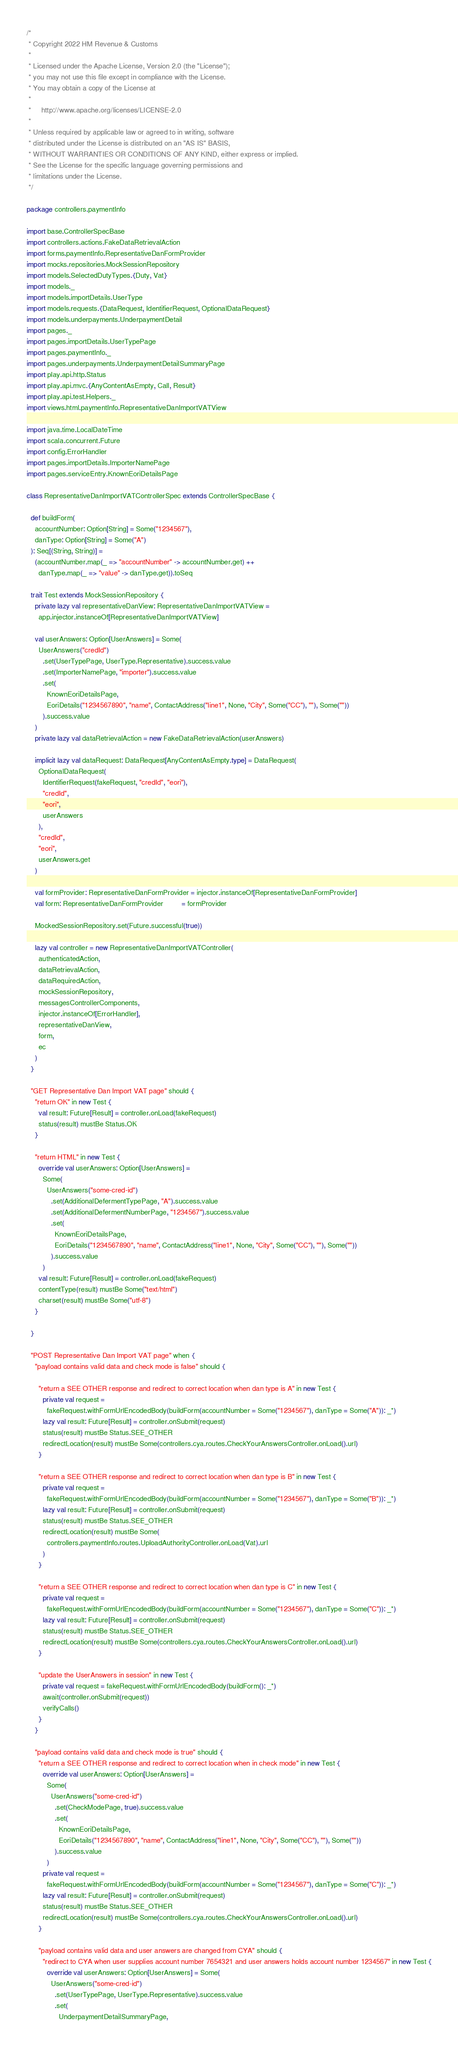<code> <loc_0><loc_0><loc_500><loc_500><_Scala_>/*
 * Copyright 2022 HM Revenue & Customs
 *
 * Licensed under the Apache License, Version 2.0 (the "License");
 * you may not use this file except in compliance with the License.
 * You may obtain a copy of the License at
 *
 *     http://www.apache.org/licenses/LICENSE-2.0
 *
 * Unless required by applicable law or agreed to in writing, software
 * distributed under the License is distributed on an "AS IS" BASIS,
 * WITHOUT WARRANTIES OR CONDITIONS OF ANY KIND, either express or implied.
 * See the License for the specific language governing permissions and
 * limitations under the License.
 */

package controllers.paymentInfo

import base.ControllerSpecBase
import controllers.actions.FakeDataRetrievalAction
import forms.paymentInfo.RepresentativeDanFormProvider
import mocks.repositories.MockSessionRepository
import models.SelectedDutyTypes.{Duty, Vat}
import models._
import models.importDetails.UserType
import models.requests.{DataRequest, IdentifierRequest, OptionalDataRequest}
import models.underpayments.UnderpaymentDetail
import pages._
import pages.importDetails.UserTypePage
import pages.paymentInfo._
import pages.underpayments.UnderpaymentDetailSummaryPage
import play.api.http.Status
import play.api.mvc.{AnyContentAsEmpty, Call, Result}
import play.api.test.Helpers._
import views.html.paymentInfo.RepresentativeDanImportVATView

import java.time.LocalDateTime
import scala.concurrent.Future
import config.ErrorHandler
import pages.importDetails.ImporterNamePage
import pages.serviceEntry.KnownEoriDetailsPage

class RepresentativeDanImportVATControllerSpec extends ControllerSpecBase {

  def buildForm(
    accountNumber: Option[String] = Some("1234567"),
    danType: Option[String] = Some("A")
  ): Seq[(String, String)] =
    (accountNumber.map(_ => "accountNumber" -> accountNumber.get) ++
      danType.map(_ => "value" -> danType.get)).toSeq

  trait Test extends MockSessionRepository {
    private lazy val representativeDanView: RepresentativeDanImportVATView =
      app.injector.instanceOf[RepresentativeDanImportVATView]

    val userAnswers: Option[UserAnswers] = Some(
      UserAnswers("credId")
        .set(UserTypePage, UserType.Representative).success.value
        .set(ImporterNamePage, "importer").success.value
        .set(
          KnownEoriDetailsPage,
          EoriDetails("1234567890", "name", ContactAddress("line1", None, "City", Some("CC"), ""), Some(""))
        ).success.value
    )
    private lazy val dataRetrievalAction = new FakeDataRetrievalAction(userAnswers)

    implicit lazy val dataRequest: DataRequest[AnyContentAsEmpty.type] = DataRequest(
      OptionalDataRequest(
        IdentifierRequest(fakeRequest, "credId", "eori"),
        "credId",
        "eori",
        userAnswers
      ),
      "credId",
      "eori",
      userAnswers.get
    )

    val formProvider: RepresentativeDanFormProvider = injector.instanceOf[RepresentativeDanFormProvider]
    val form: RepresentativeDanFormProvider         = formProvider

    MockedSessionRepository.set(Future.successful(true))

    lazy val controller = new RepresentativeDanImportVATController(
      authenticatedAction,
      dataRetrievalAction,
      dataRequiredAction,
      mockSessionRepository,
      messagesControllerComponents,
      injector.instanceOf[ErrorHandler],
      representativeDanView,
      form,
      ec
    )
  }

  "GET Representative Dan Import VAT page" should {
    "return OK" in new Test {
      val result: Future[Result] = controller.onLoad(fakeRequest)
      status(result) mustBe Status.OK
    }

    "return HTML" in new Test {
      override val userAnswers: Option[UserAnswers] =
        Some(
          UserAnswers("some-cred-id")
            .set(AdditionalDefermentTypePage, "A").success.value
            .set(AdditionalDefermentNumberPage, "1234567").success.value
            .set(
              KnownEoriDetailsPage,
              EoriDetails("1234567890", "name", ContactAddress("line1", None, "City", Some("CC"), ""), Some(""))
            ).success.value
        )
      val result: Future[Result] = controller.onLoad(fakeRequest)
      contentType(result) mustBe Some("text/html")
      charset(result) mustBe Some("utf-8")
    }

  }

  "POST Representative Dan Import VAT page" when {
    "payload contains valid data and check mode is false" should {

      "return a SEE OTHER response and redirect to correct location when dan type is A" in new Test {
        private val request =
          fakeRequest.withFormUrlEncodedBody(buildForm(accountNumber = Some("1234567"), danType = Some("A")): _*)
        lazy val result: Future[Result] = controller.onSubmit(request)
        status(result) mustBe Status.SEE_OTHER
        redirectLocation(result) mustBe Some(controllers.cya.routes.CheckYourAnswersController.onLoad().url)
      }

      "return a SEE OTHER response and redirect to correct location when dan type is B" in new Test {
        private val request =
          fakeRequest.withFormUrlEncodedBody(buildForm(accountNumber = Some("1234567"), danType = Some("B")): _*)
        lazy val result: Future[Result] = controller.onSubmit(request)
        status(result) mustBe Status.SEE_OTHER
        redirectLocation(result) mustBe Some(
          controllers.paymentInfo.routes.UploadAuthorityController.onLoad(Vat).url
        )
      }

      "return a SEE OTHER response and redirect to correct location when dan type is C" in new Test {
        private val request =
          fakeRequest.withFormUrlEncodedBody(buildForm(accountNumber = Some("1234567"), danType = Some("C")): _*)
        lazy val result: Future[Result] = controller.onSubmit(request)
        status(result) mustBe Status.SEE_OTHER
        redirectLocation(result) mustBe Some(controllers.cya.routes.CheckYourAnswersController.onLoad().url)
      }

      "update the UserAnswers in session" in new Test {
        private val request = fakeRequest.withFormUrlEncodedBody(buildForm(): _*)
        await(controller.onSubmit(request))
        verifyCalls()
      }
    }

    "payload contains valid data and check mode is true" should {
      "return a SEE OTHER response and redirect to correct location when in check mode" in new Test {
        override val userAnswers: Option[UserAnswers] =
          Some(
            UserAnswers("some-cred-id")
              .set(CheckModePage, true).success.value
              .set(
                KnownEoriDetailsPage,
                EoriDetails("1234567890", "name", ContactAddress("line1", None, "City", Some("CC"), ""), Some(""))
              ).success.value
          )
        private val request =
          fakeRequest.withFormUrlEncodedBody(buildForm(accountNumber = Some("1234567"), danType = Some("C")): _*)
        lazy val result: Future[Result] = controller.onSubmit(request)
        status(result) mustBe Status.SEE_OTHER
        redirectLocation(result) mustBe Some(controllers.cya.routes.CheckYourAnswersController.onLoad().url)
      }

      "payload contains valid data and user answers are changed from CYA" should {
        "redirect to CYA when user supplies account number 7654321 and user answers holds account number 1234567" in new Test {
          override val userAnswers: Option[UserAnswers] = Some(
            UserAnswers("some-cred-id")
              .set(UserTypePage, UserType.Representative).success.value
              .set(
                UnderpaymentDetailSummaryPage,</code> 